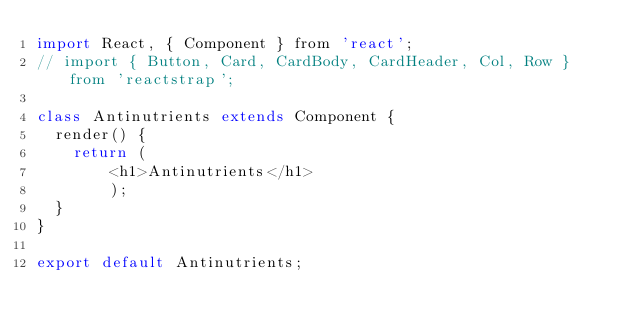Convert code to text. <code><loc_0><loc_0><loc_500><loc_500><_JavaScript_>import React, { Component } from 'react';
// import { Button, Card, CardBody, CardHeader, Col, Row } from 'reactstrap';

class Antinutrients extends Component {
  render() {
    return (
    	<h1>Antinutrients</h1>
    	);
  }
}

export default Antinutrients;</code> 